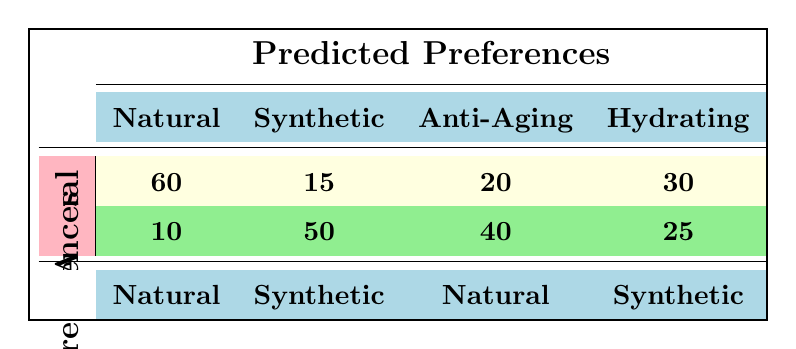What is the total number of customers who preferred Natural products? To find the total number of customers who preferred Natural products, I will look at the column labeled 'Natural' under 'Actual Preferences'. The value here is 60 for those who actually preferred Natural and 15 who preferred Synthetic but were predicted as Natural, summing these gives 60 + 15 = 75.
Answer: 75 What is the count of customers correctly predicted as preferring Synthetic products? In the table, the count of customers who actually preferred Synthetic products and were predicted as Synthetic is found in the 'Synthetic' row under 'Actual Preferences'. The value is 50.
Answer: 50 Which predicted preference had the highest number of customers with actual Natural preference? Looking at the table, the 'Natural' row under actual preferences shows 60, while other predicted preferences show 15, 20, and 30 for Synthetic, Anti-Aging, and Hydrating respectively. The highest number of actual preference for Natural is clearly from the prediction of Natural products which is 60.
Answer: Natural What is the total number of customers who were predicted to prefer Hydrating products? To find this, I will look at the Hydrating row for both actual preferences (Natural and Synthetic). The data shows 30 for Natural and 25 for Synthetic. Adding these gives 30 + 25 = 55.
Answer: 55 Is it true that more customers actually preferred Synthetic products than Natural products? To determine this, I will compare the totals mentioned in the table. The actual preferences show 10 for Synthetic and 60 for Natural. As 60 is greater than 10, the statement is false.
Answer: No What is the difference between the number of customers who preferred Anti-Aging products and those who preferred Hydrating products as predicted? For Anti-Aging, under 'Predicted Preferences', the value is 20 for Natural and 40 for Synthetic, totaling 20 + 40 = 60. For Hydrating, the values are 30 (Natural) and 25 (Synthetic), totaling 30 + 25 = 55. The difference is 60 - 55 = 5.
Answer: 5 How many customers were predicted to prefer Synthetic products but actually preferred Natural? Referring to the 'Predicted Preferences' for Synthetic and looking at 'Actual Preferences' for Natural shows 15 customers were predicted as Synthetic but preferred Natural.
Answer: 15 What is the combined total of customers who preferred both Anti-Aging and Hydrating products as predicted? For Anti-Aging, the totals are 20 (Natural) and 40 (Synthetic), giving a total of 60. For Hydrating, the totals are 30 (Natural) and 25 (Synthetic), giving a total of 55. The combined total is 60 + 55 = 115.
Answer: 115 